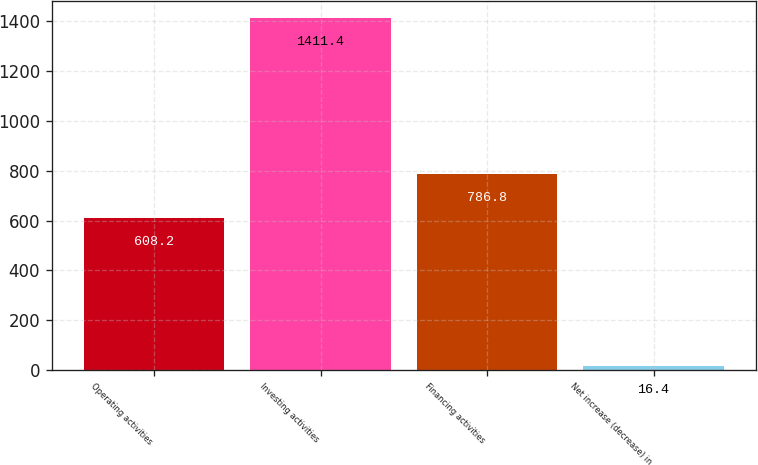Convert chart. <chart><loc_0><loc_0><loc_500><loc_500><bar_chart><fcel>Operating activities<fcel>Investing activities<fcel>Financing activities<fcel>Net increase (decrease) in<nl><fcel>608.2<fcel>1411.4<fcel>786.8<fcel>16.4<nl></chart> 